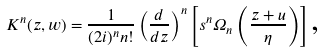<formula> <loc_0><loc_0><loc_500><loc_500>K ^ { n } ( z , w ) = \frac { 1 } { ( 2 i ) ^ { n } n ! } \left ( \frac { d } { d z } \right ) ^ { n } \left [ s ^ { n } \Omega _ { n } \left ( \frac { z + u } { \eta } \right ) \right ] \text {,}</formula> 